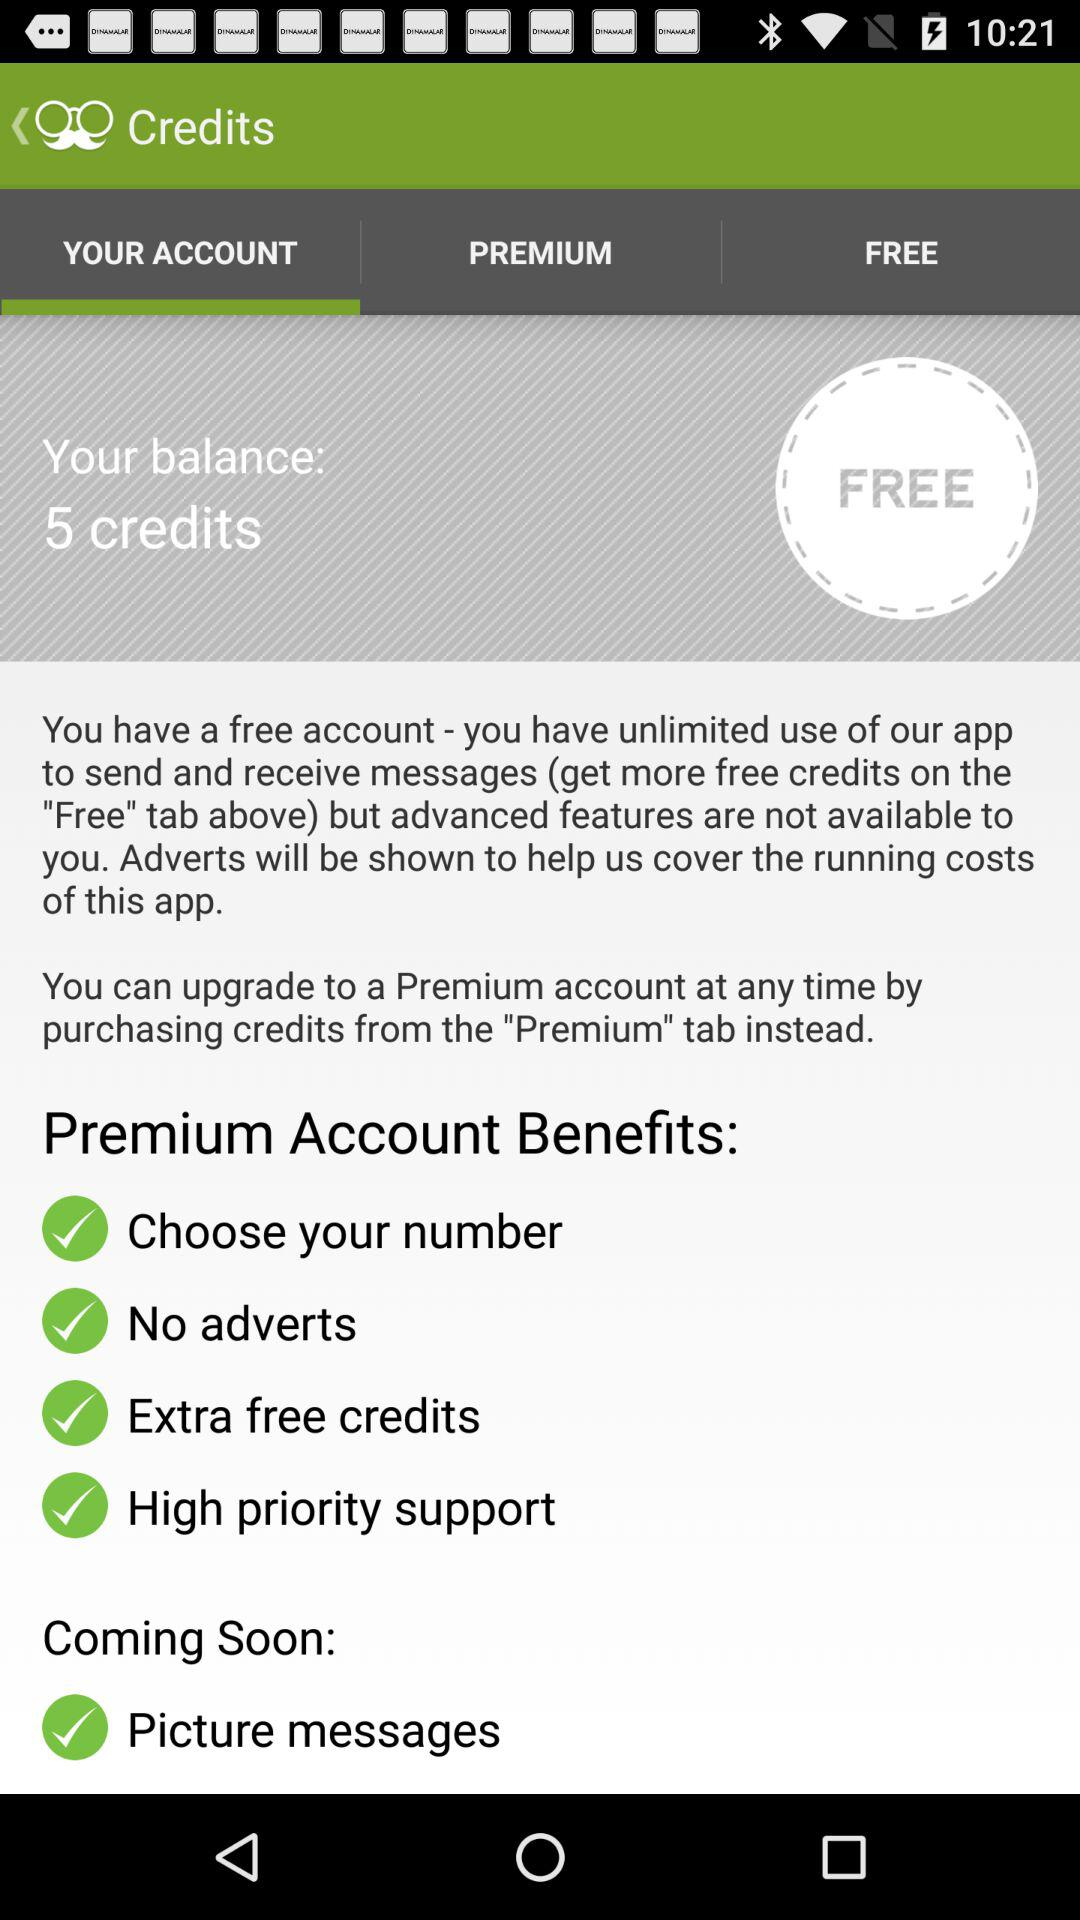Which feature is coming soon? The "Picture messages" feature is coming soon. 